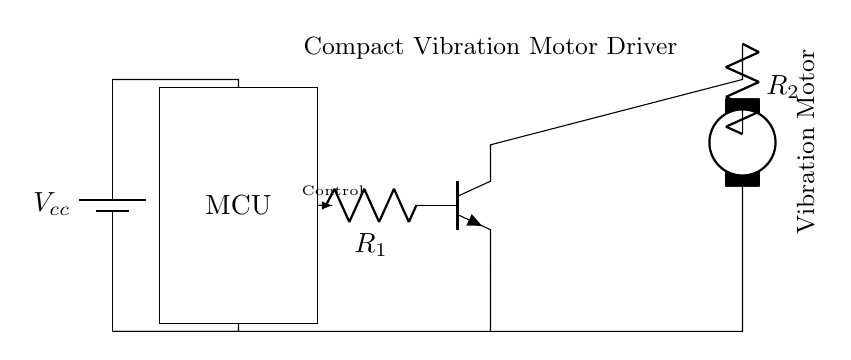What is the main purpose of this circuit? The circuit is designed as a compact vibration motor driver for silent notifications in mobile devices. This can be inferred from the label and function of the components, specifically the vibration motor.
Answer: Vibration motor driver What type of transistor is used in this circuit? The circuit utilizes an NPN transistor, which is indicated by the npn notation in the drawing. This type of transistor is commonly used for switching applications in driver circuits.
Answer: NPN How many resistors are present in the circuit? There are two resistors labeled as R1 and R2 in the circuit diagram. They are connected to different components.
Answer: Two What connects the microcontroller to the base of the transistor? The microcontroller is connected to the base of the NPN transistor through resistor R1, which allows a control signal to drive the transistor.
Answer: Resistor What is the function of the resistor R2? Resistor R2 is in series with the vibration motor, and its function is to limit the current flowing into the motor, preventing excessive current that could damage the component.
Answer: Limit current What voltage is supplied to the circuit? The circuit is powered by a battery, indicated as Vcc, but the specific voltage value is not provided in the circuit drawing itself.
Answer: Vcc What component is responsible for controlling the vibration motor's operation? The microcontroller (MCU) is responsible for controlling the operation of the vibration motor by sending a control signal to the transistor, which in turn activates the motor.
Answer: MCU 